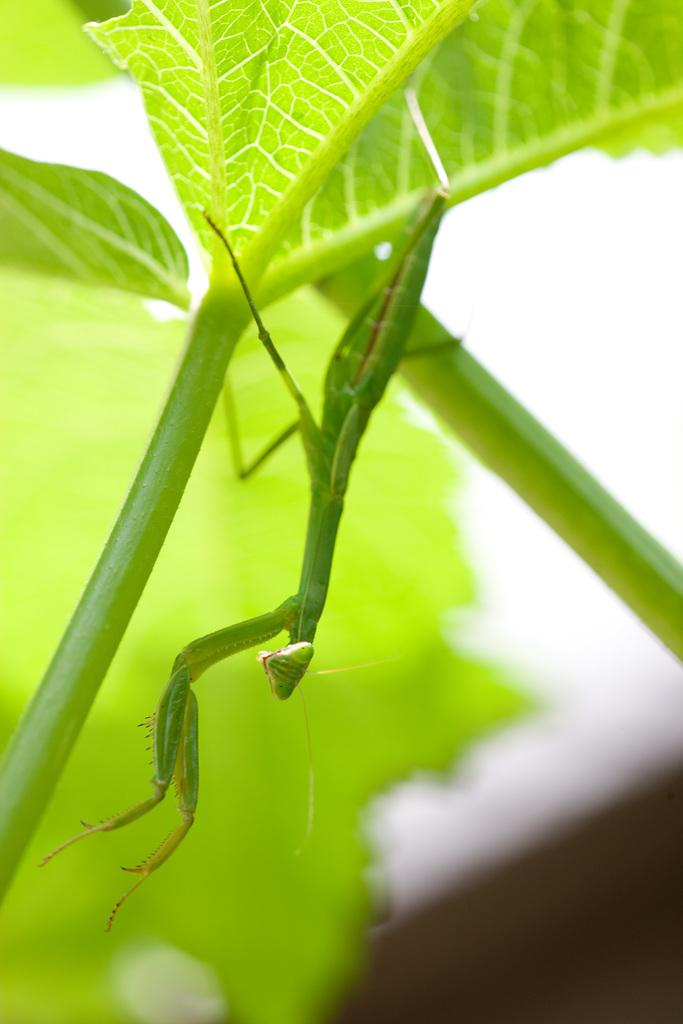What is the main subject of the image? There is an insect on a leaf in the image. How is the background of the image depicted? The background of the image is blurred. What can be seen in the background of the image besides the blurred area? There is a leaf and an object visible in the background of the image. What type of fruit is hanging from the leaf in the image? There is no fruit hanging from the leaf in the image; it is an insect on the leaf. What kind of leather material can be seen in the image? There is no leather material present in the image. 